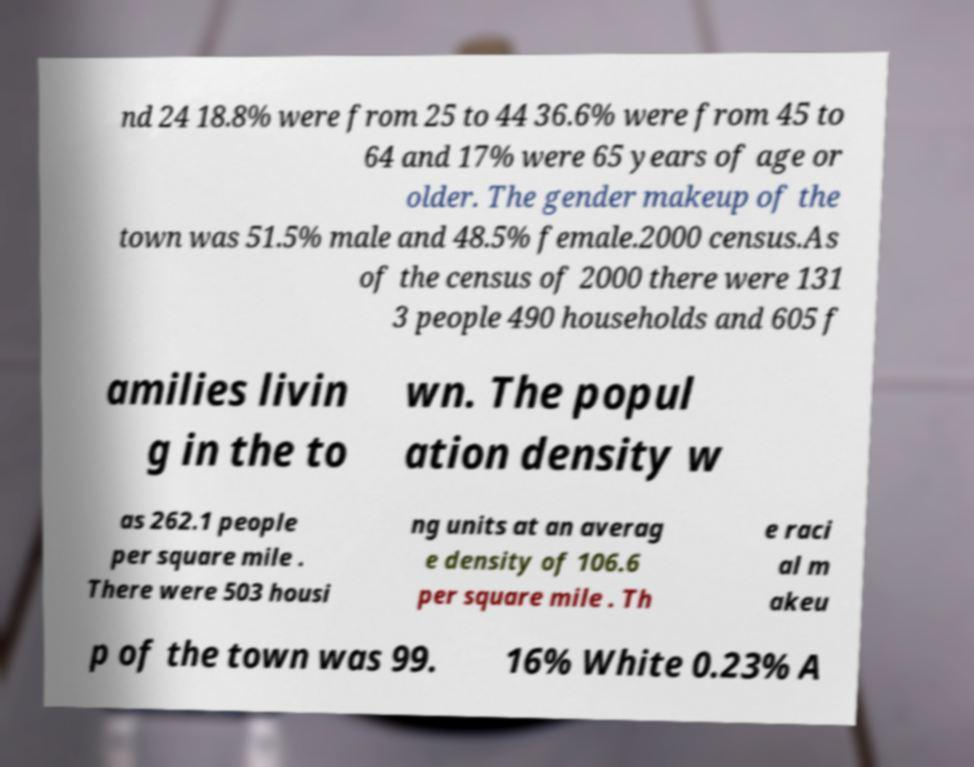For documentation purposes, I need the text within this image transcribed. Could you provide that? nd 24 18.8% were from 25 to 44 36.6% were from 45 to 64 and 17% were 65 years of age or older. The gender makeup of the town was 51.5% male and 48.5% female.2000 census.As of the census of 2000 there were 131 3 people 490 households and 605 f amilies livin g in the to wn. The popul ation density w as 262.1 people per square mile . There were 503 housi ng units at an averag e density of 106.6 per square mile . Th e raci al m akeu p of the town was 99. 16% White 0.23% A 